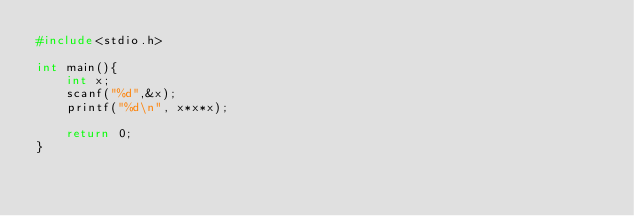Convert code to text. <code><loc_0><loc_0><loc_500><loc_500><_C_>#include<stdio.h>

int main(){
    int x;
    scanf("%d",&x);
    printf("%d\n", x*x*x);    

    return 0;
}
</code> 